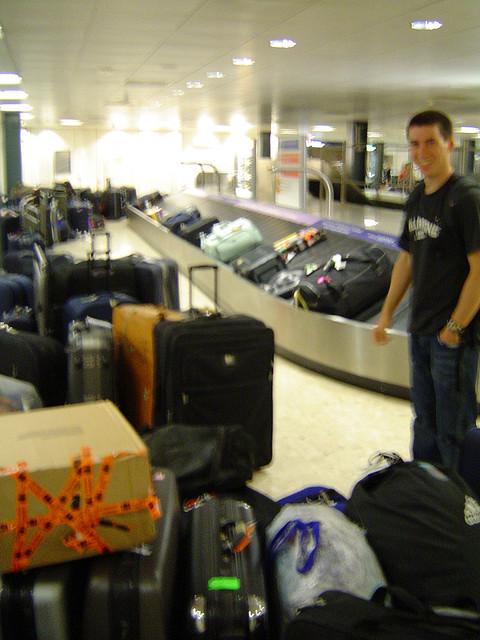Does one person own all this luggage?
Write a very short answer. No. How many suitcases are rolling?
Quick response, please. 6. Is there any pink luggage?
Short answer required. No. Where is this person?
Short answer required. Airport. Are people waiting for their luggage?
Quick response, please. Yes. How many cardboard boxes are there in this scene?
Keep it brief. 1. What is on the man's wrist?
Keep it brief. Watch. How many people are pictured?
Keep it brief. 1. What color tape is on the box?
Answer briefly. Orange. 